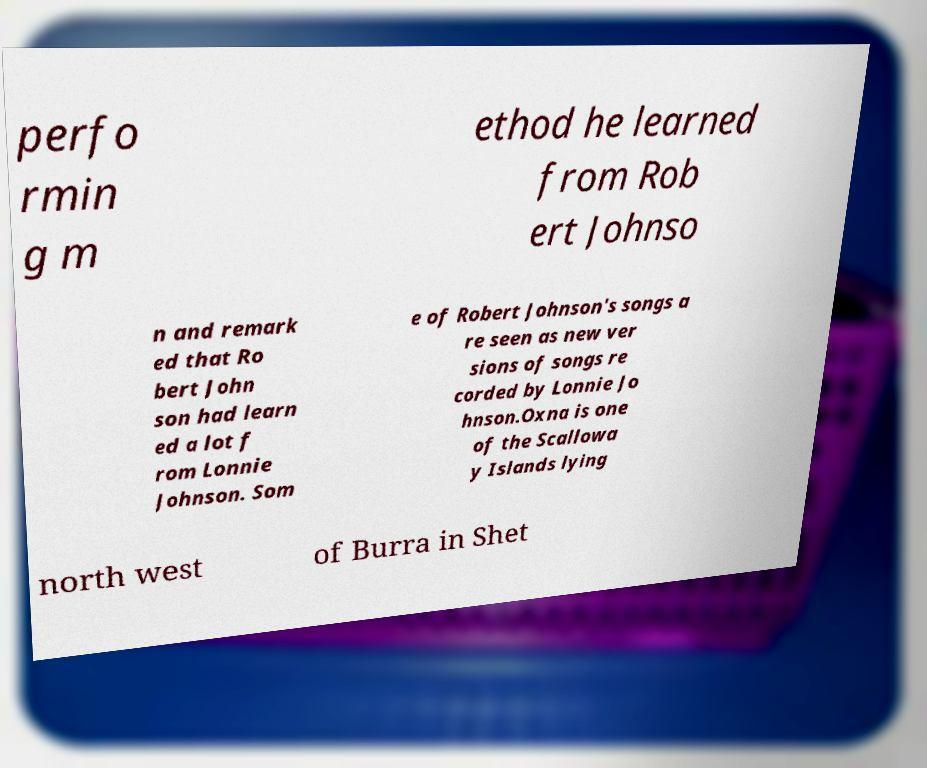Please read and relay the text visible in this image. What does it say? perfo rmin g m ethod he learned from Rob ert Johnso n and remark ed that Ro bert John son had learn ed a lot f rom Lonnie Johnson. Som e of Robert Johnson's songs a re seen as new ver sions of songs re corded by Lonnie Jo hnson.Oxna is one of the Scallowa y Islands lying north west of Burra in Shet 